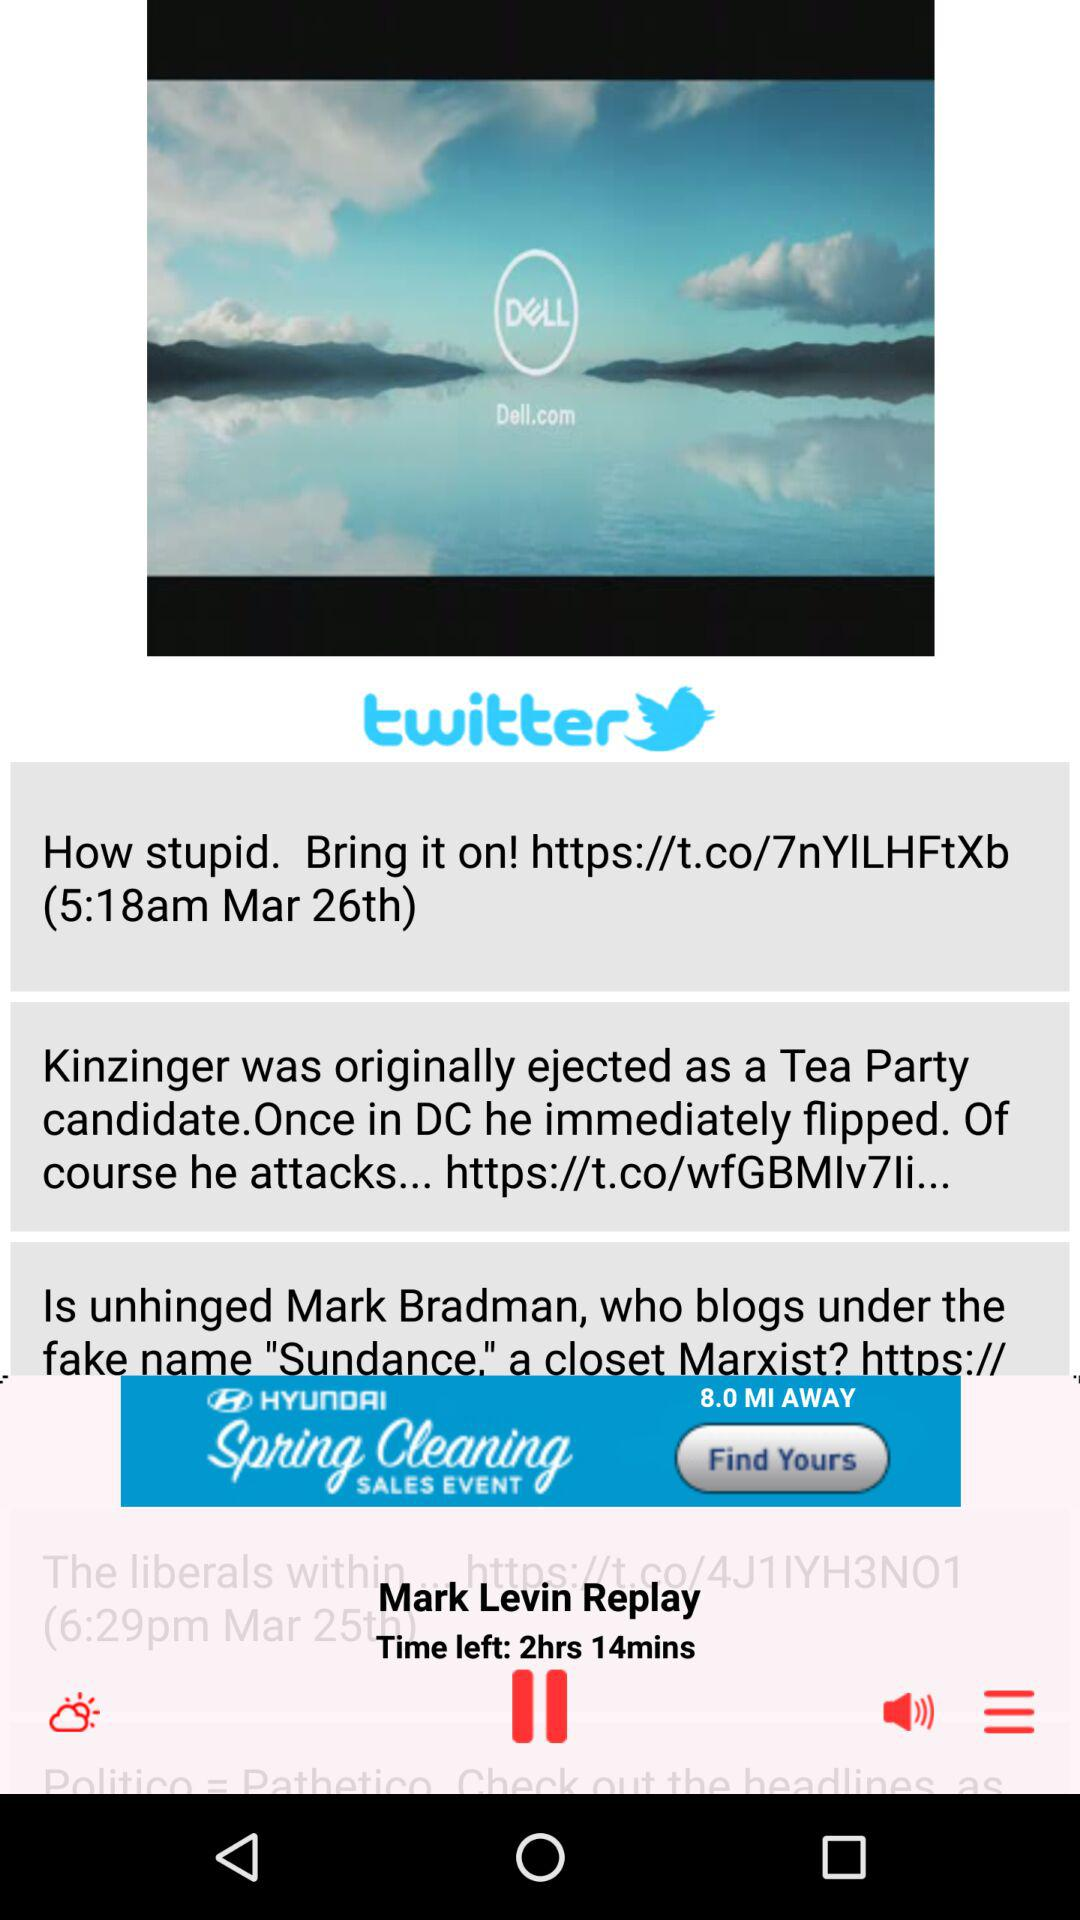How is the weather? The weather is partly cloudy. 